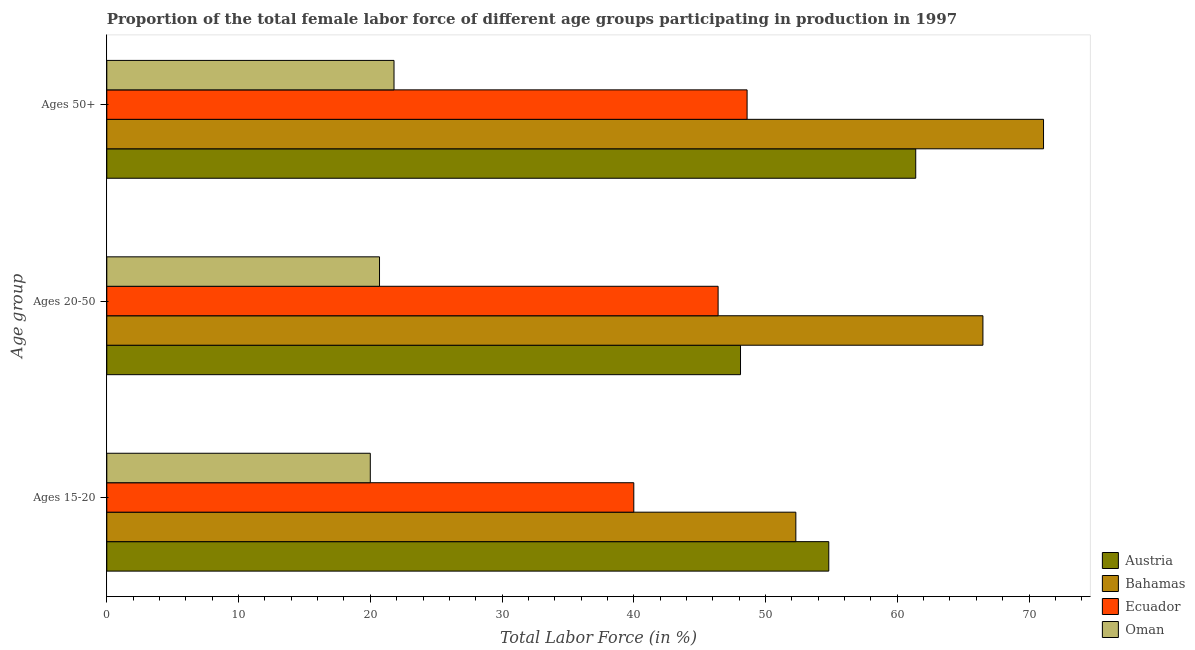How many different coloured bars are there?
Your response must be concise. 4. Are the number of bars on each tick of the Y-axis equal?
Provide a short and direct response. Yes. How many bars are there on the 1st tick from the top?
Keep it short and to the point. 4. What is the label of the 3rd group of bars from the top?
Provide a short and direct response. Ages 15-20. What is the percentage of female labor force within the age group 20-50 in Austria?
Offer a terse response. 48.1. Across all countries, what is the maximum percentage of female labor force above age 50?
Your answer should be very brief. 71.1. Across all countries, what is the minimum percentage of female labor force within the age group 15-20?
Provide a succinct answer. 20. In which country was the percentage of female labor force within the age group 20-50 maximum?
Ensure brevity in your answer.  Bahamas. In which country was the percentage of female labor force above age 50 minimum?
Give a very brief answer. Oman. What is the total percentage of female labor force within the age group 20-50 in the graph?
Your response must be concise. 181.7. What is the difference between the percentage of female labor force above age 50 in Ecuador and that in Bahamas?
Your answer should be very brief. -22.5. What is the difference between the percentage of female labor force above age 50 in Oman and the percentage of female labor force within the age group 15-20 in Ecuador?
Provide a short and direct response. -18.2. What is the average percentage of female labor force within the age group 20-50 per country?
Your answer should be compact. 45.43. What is the difference between the percentage of female labor force above age 50 and percentage of female labor force within the age group 15-20 in Oman?
Give a very brief answer. 1.8. What is the ratio of the percentage of female labor force above age 50 in Oman to that in Austria?
Provide a succinct answer. 0.36. Is the percentage of female labor force above age 50 in Bahamas less than that in Ecuador?
Offer a very short reply. No. What is the difference between the highest and the second highest percentage of female labor force within the age group 20-50?
Keep it short and to the point. 18.4. What is the difference between the highest and the lowest percentage of female labor force within the age group 15-20?
Provide a short and direct response. 34.8. Is the sum of the percentage of female labor force within the age group 20-50 in Bahamas and Austria greater than the maximum percentage of female labor force within the age group 15-20 across all countries?
Your answer should be compact. Yes. What does the 3rd bar from the top in Ages 20-50 represents?
Your response must be concise. Bahamas. What does the 4th bar from the bottom in Ages 50+ represents?
Keep it short and to the point. Oman. How many bars are there?
Ensure brevity in your answer.  12. How many countries are there in the graph?
Offer a very short reply. 4. What is the difference between two consecutive major ticks on the X-axis?
Provide a short and direct response. 10. Does the graph contain any zero values?
Your answer should be very brief. No. How many legend labels are there?
Ensure brevity in your answer.  4. What is the title of the graph?
Your answer should be very brief. Proportion of the total female labor force of different age groups participating in production in 1997. What is the label or title of the Y-axis?
Your answer should be compact. Age group. What is the Total Labor Force (in %) of Austria in Ages 15-20?
Give a very brief answer. 54.8. What is the Total Labor Force (in %) of Bahamas in Ages 15-20?
Keep it short and to the point. 52.3. What is the Total Labor Force (in %) in Oman in Ages 15-20?
Provide a succinct answer. 20. What is the Total Labor Force (in %) of Austria in Ages 20-50?
Provide a short and direct response. 48.1. What is the Total Labor Force (in %) of Bahamas in Ages 20-50?
Offer a very short reply. 66.5. What is the Total Labor Force (in %) in Ecuador in Ages 20-50?
Give a very brief answer. 46.4. What is the Total Labor Force (in %) of Oman in Ages 20-50?
Provide a short and direct response. 20.7. What is the Total Labor Force (in %) of Austria in Ages 50+?
Make the answer very short. 61.4. What is the Total Labor Force (in %) of Bahamas in Ages 50+?
Ensure brevity in your answer.  71.1. What is the Total Labor Force (in %) in Ecuador in Ages 50+?
Your response must be concise. 48.6. What is the Total Labor Force (in %) in Oman in Ages 50+?
Offer a terse response. 21.8. Across all Age group, what is the maximum Total Labor Force (in %) in Austria?
Provide a succinct answer. 61.4. Across all Age group, what is the maximum Total Labor Force (in %) of Bahamas?
Provide a succinct answer. 71.1. Across all Age group, what is the maximum Total Labor Force (in %) of Ecuador?
Give a very brief answer. 48.6. Across all Age group, what is the maximum Total Labor Force (in %) in Oman?
Keep it short and to the point. 21.8. Across all Age group, what is the minimum Total Labor Force (in %) of Austria?
Ensure brevity in your answer.  48.1. Across all Age group, what is the minimum Total Labor Force (in %) of Bahamas?
Offer a very short reply. 52.3. Across all Age group, what is the minimum Total Labor Force (in %) of Oman?
Provide a succinct answer. 20. What is the total Total Labor Force (in %) of Austria in the graph?
Your answer should be very brief. 164.3. What is the total Total Labor Force (in %) of Bahamas in the graph?
Keep it short and to the point. 189.9. What is the total Total Labor Force (in %) in Ecuador in the graph?
Your answer should be very brief. 135. What is the total Total Labor Force (in %) of Oman in the graph?
Offer a terse response. 62.5. What is the difference between the Total Labor Force (in %) of Austria in Ages 15-20 and that in Ages 50+?
Offer a terse response. -6.6. What is the difference between the Total Labor Force (in %) of Bahamas in Ages 15-20 and that in Ages 50+?
Keep it short and to the point. -18.8. What is the difference between the Total Labor Force (in %) of Ecuador in Ages 15-20 and that in Ages 50+?
Provide a succinct answer. -8.6. What is the difference between the Total Labor Force (in %) in Oman in Ages 15-20 and that in Ages 50+?
Provide a short and direct response. -1.8. What is the difference between the Total Labor Force (in %) in Austria in Ages 20-50 and that in Ages 50+?
Offer a very short reply. -13.3. What is the difference between the Total Labor Force (in %) in Bahamas in Ages 20-50 and that in Ages 50+?
Offer a terse response. -4.6. What is the difference between the Total Labor Force (in %) of Ecuador in Ages 20-50 and that in Ages 50+?
Your answer should be compact. -2.2. What is the difference between the Total Labor Force (in %) of Oman in Ages 20-50 and that in Ages 50+?
Ensure brevity in your answer.  -1.1. What is the difference between the Total Labor Force (in %) of Austria in Ages 15-20 and the Total Labor Force (in %) of Bahamas in Ages 20-50?
Give a very brief answer. -11.7. What is the difference between the Total Labor Force (in %) of Austria in Ages 15-20 and the Total Labor Force (in %) of Oman in Ages 20-50?
Your answer should be compact. 34.1. What is the difference between the Total Labor Force (in %) in Bahamas in Ages 15-20 and the Total Labor Force (in %) in Oman in Ages 20-50?
Give a very brief answer. 31.6. What is the difference between the Total Labor Force (in %) in Ecuador in Ages 15-20 and the Total Labor Force (in %) in Oman in Ages 20-50?
Keep it short and to the point. 19.3. What is the difference between the Total Labor Force (in %) in Austria in Ages 15-20 and the Total Labor Force (in %) in Bahamas in Ages 50+?
Offer a very short reply. -16.3. What is the difference between the Total Labor Force (in %) in Austria in Ages 15-20 and the Total Labor Force (in %) in Ecuador in Ages 50+?
Ensure brevity in your answer.  6.2. What is the difference between the Total Labor Force (in %) in Bahamas in Ages 15-20 and the Total Labor Force (in %) in Oman in Ages 50+?
Keep it short and to the point. 30.5. What is the difference between the Total Labor Force (in %) of Ecuador in Ages 15-20 and the Total Labor Force (in %) of Oman in Ages 50+?
Offer a terse response. 18.2. What is the difference between the Total Labor Force (in %) of Austria in Ages 20-50 and the Total Labor Force (in %) of Bahamas in Ages 50+?
Make the answer very short. -23. What is the difference between the Total Labor Force (in %) in Austria in Ages 20-50 and the Total Labor Force (in %) in Ecuador in Ages 50+?
Provide a short and direct response. -0.5. What is the difference between the Total Labor Force (in %) in Austria in Ages 20-50 and the Total Labor Force (in %) in Oman in Ages 50+?
Ensure brevity in your answer.  26.3. What is the difference between the Total Labor Force (in %) in Bahamas in Ages 20-50 and the Total Labor Force (in %) in Ecuador in Ages 50+?
Keep it short and to the point. 17.9. What is the difference between the Total Labor Force (in %) in Bahamas in Ages 20-50 and the Total Labor Force (in %) in Oman in Ages 50+?
Your answer should be very brief. 44.7. What is the difference between the Total Labor Force (in %) in Ecuador in Ages 20-50 and the Total Labor Force (in %) in Oman in Ages 50+?
Keep it short and to the point. 24.6. What is the average Total Labor Force (in %) of Austria per Age group?
Provide a short and direct response. 54.77. What is the average Total Labor Force (in %) of Bahamas per Age group?
Your response must be concise. 63.3. What is the average Total Labor Force (in %) in Oman per Age group?
Your response must be concise. 20.83. What is the difference between the Total Labor Force (in %) in Austria and Total Labor Force (in %) in Ecuador in Ages 15-20?
Offer a terse response. 14.8. What is the difference between the Total Labor Force (in %) of Austria and Total Labor Force (in %) of Oman in Ages 15-20?
Your answer should be compact. 34.8. What is the difference between the Total Labor Force (in %) in Bahamas and Total Labor Force (in %) in Ecuador in Ages 15-20?
Your answer should be compact. 12.3. What is the difference between the Total Labor Force (in %) in Bahamas and Total Labor Force (in %) in Oman in Ages 15-20?
Provide a succinct answer. 32.3. What is the difference between the Total Labor Force (in %) in Ecuador and Total Labor Force (in %) in Oman in Ages 15-20?
Offer a very short reply. 20. What is the difference between the Total Labor Force (in %) in Austria and Total Labor Force (in %) in Bahamas in Ages 20-50?
Offer a terse response. -18.4. What is the difference between the Total Labor Force (in %) in Austria and Total Labor Force (in %) in Oman in Ages 20-50?
Offer a terse response. 27.4. What is the difference between the Total Labor Force (in %) in Bahamas and Total Labor Force (in %) in Ecuador in Ages 20-50?
Keep it short and to the point. 20.1. What is the difference between the Total Labor Force (in %) in Bahamas and Total Labor Force (in %) in Oman in Ages 20-50?
Your answer should be very brief. 45.8. What is the difference between the Total Labor Force (in %) of Ecuador and Total Labor Force (in %) of Oman in Ages 20-50?
Your answer should be very brief. 25.7. What is the difference between the Total Labor Force (in %) in Austria and Total Labor Force (in %) in Oman in Ages 50+?
Offer a very short reply. 39.6. What is the difference between the Total Labor Force (in %) of Bahamas and Total Labor Force (in %) of Ecuador in Ages 50+?
Keep it short and to the point. 22.5. What is the difference between the Total Labor Force (in %) of Bahamas and Total Labor Force (in %) of Oman in Ages 50+?
Your answer should be compact. 49.3. What is the difference between the Total Labor Force (in %) of Ecuador and Total Labor Force (in %) of Oman in Ages 50+?
Your response must be concise. 26.8. What is the ratio of the Total Labor Force (in %) of Austria in Ages 15-20 to that in Ages 20-50?
Provide a succinct answer. 1.14. What is the ratio of the Total Labor Force (in %) of Bahamas in Ages 15-20 to that in Ages 20-50?
Make the answer very short. 0.79. What is the ratio of the Total Labor Force (in %) in Ecuador in Ages 15-20 to that in Ages 20-50?
Provide a succinct answer. 0.86. What is the ratio of the Total Labor Force (in %) in Oman in Ages 15-20 to that in Ages 20-50?
Provide a succinct answer. 0.97. What is the ratio of the Total Labor Force (in %) in Austria in Ages 15-20 to that in Ages 50+?
Offer a very short reply. 0.89. What is the ratio of the Total Labor Force (in %) of Bahamas in Ages 15-20 to that in Ages 50+?
Keep it short and to the point. 0.74. What is the ratio of the Total Labor Force (in %) of Ecuador in Ages 15-20 to that in Ages 50+?
Offer a terse response. 0.82. What is the ratio of the Total Labor Force (in %) of Oman in Ages 15-20 to that in Ages 50+?
Offer a very short reply. 0.92. What is the ratio of the Total Labor Force (in %) of Austria in Ages 20-50 to that in Ages 50+?
Ensure brevity in your answer.  0.78. What is the ratio of the Total Labor Force (in %) of Bahamas in Ages 20-50 to that in Ages 50+?
Provide a succinct answer. 0.94. What is the ratio of the Total Labor Force (in %) of Ecuador in Ages 20-50 to that in Ages 50+?
Ensure brevity in your answer.  0.95. What is the ratio of the Total Labor Force (in %) in Oman in Ages 20-50 to that in Ages 50+?
Your answer should be very brief. 0.95. What is the difference between the highest and the second highest Total Labor Force (in %) in Austria?
Keep it short and to the point. 6.6. What is the difference between the highest and the lowest Total Labor Force (in %) of Bahamas?
Provide a succinct answer. 18.8. What is the difference between the highest and the lowest Total Labor Force (in %) in Ecuador?
Provide a short and direct response. 8.6. What is the difference between the highest and the lowest Total Labor Force (in %) of Oman?
Offer a very short reply. 1.8. 